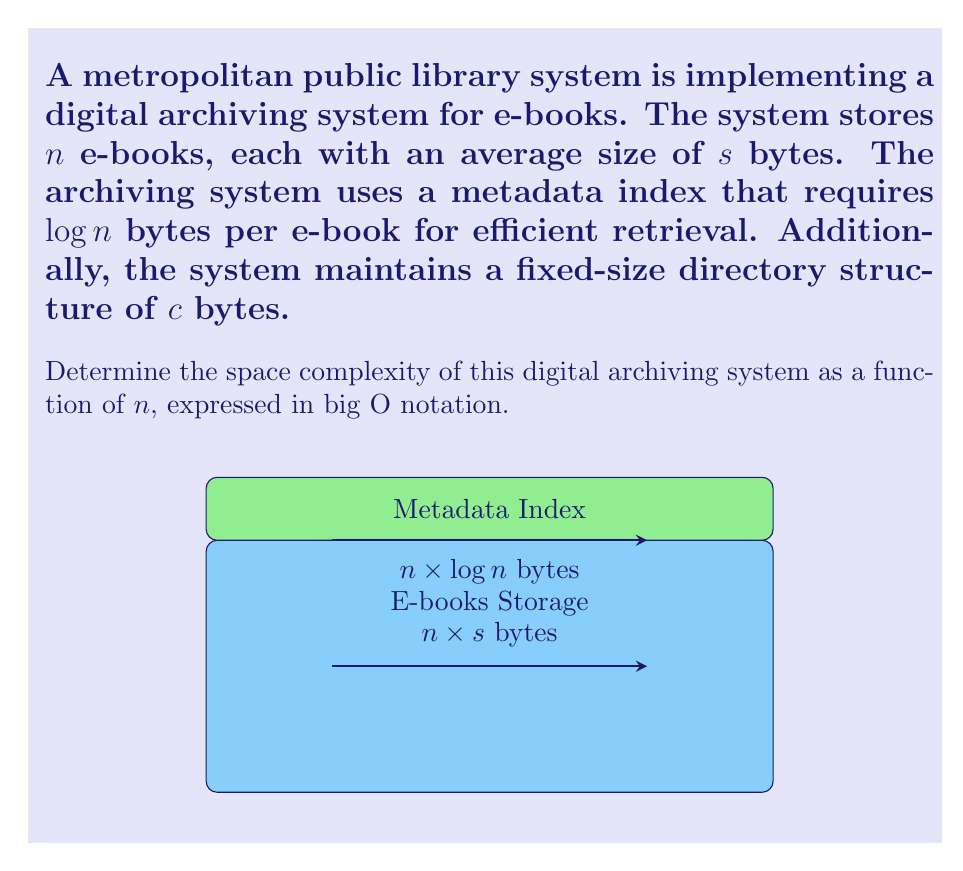Could you help me with this problem? To determine the space complexity, we need to consider all components of the system:

1. E-books storage:
   - There are $n$ e-books, each of size $s$ bytes
   - Total space for e-books: $n \times s$ bytes

2. Metadata index:
   - Each e-book requires $\log n$ bytes for indexing
   - Total space for metadata: $n \times \log n$ bytes

3. Directory structure:
   - Fixed size of $c$ bytes

The total space required is the sum of these components:

$$\text{Total Space} = (n \times s) + (n \times \log n) + c$$

To express this in big O notation, we need to consider the dominant term as $n$ grows large:

- $n \times s$ grows linearly with $n$
- $n \times \log n$ grows slightly faster than linear but slower than quadratic
- $c$ is constant and doesn't grow with $n$

The dominant term is $n \times s$, as it grows faster than $n \times \log n$ for large $n$. The constant $c$ can be dropped in big O notation.

Therefore, the space complexity is $O(n)$, where $n$ is the number of e-books.
Answer: $O(n)$ 